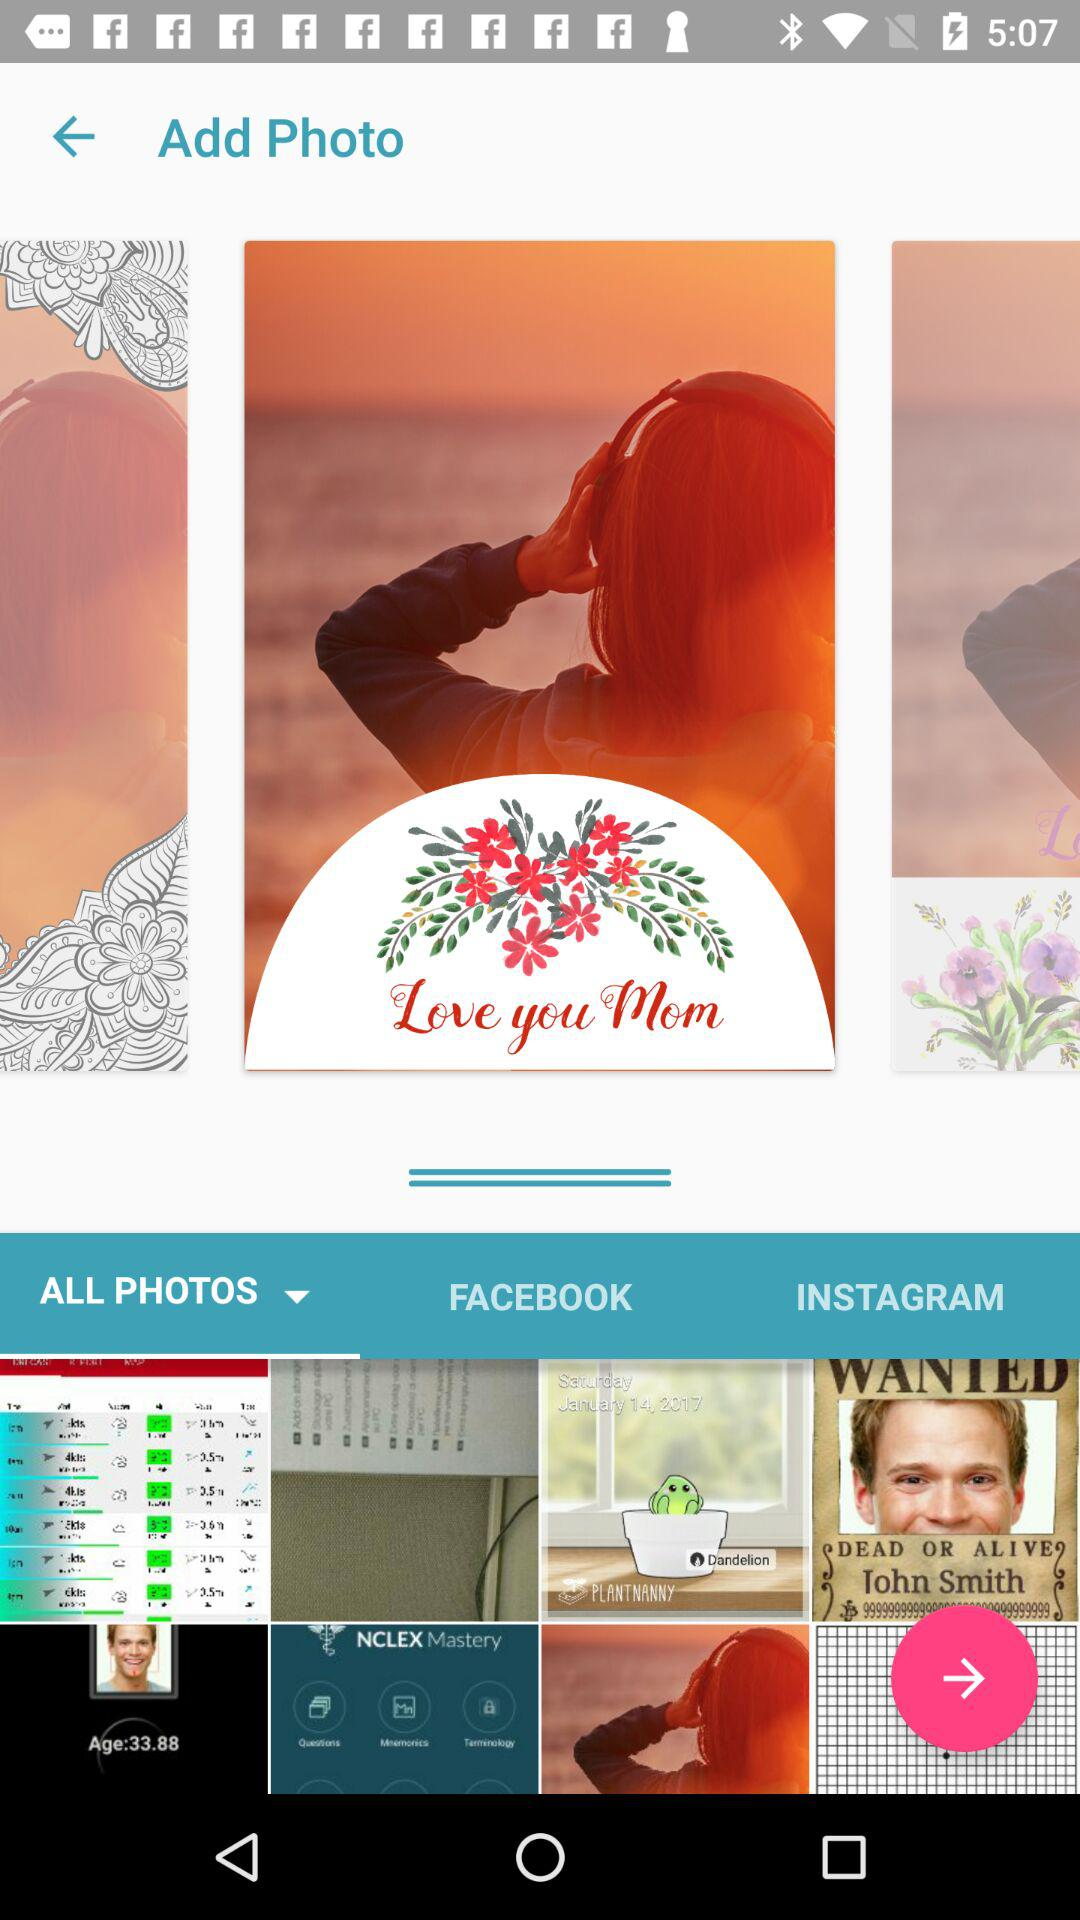Which is the selected tab? The selected tab is "ALL PHOTOS". 